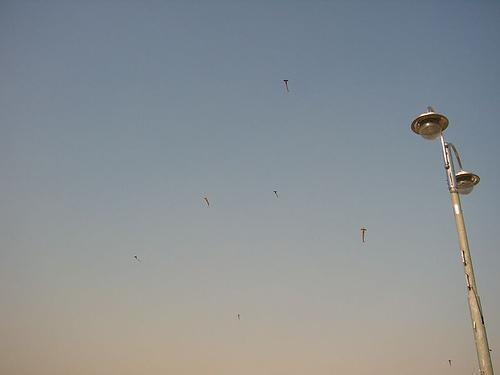How many people are shown?
Give a very brief answer. 0. 